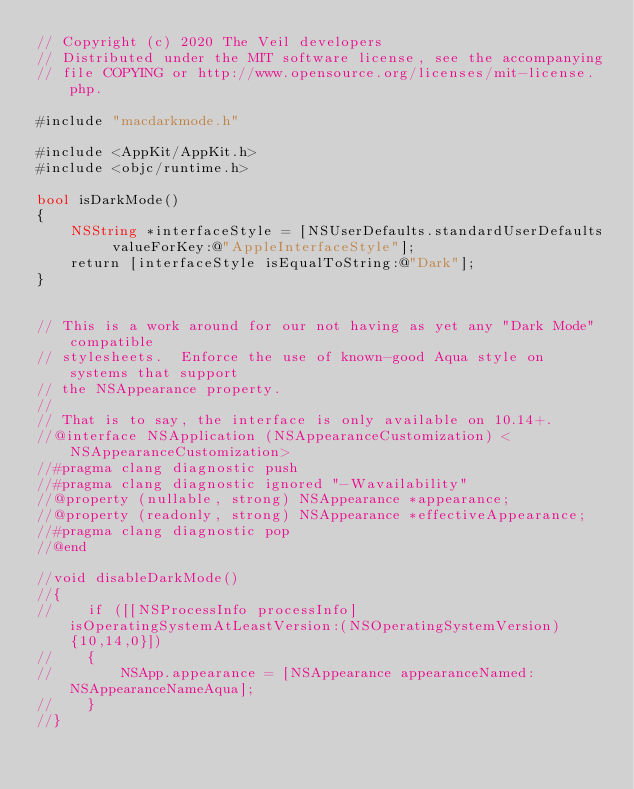Convert code to text. <code><loc_0><loc_0><loc_500><loc_500><_ObjectiveC_>// Copyright (c) 2020 The Veil developers
// Distributed under the MIT software license, see the accompanying
// file COPYING or http://www.opensource.org/licenses/mit-license.php.

#include "macdarkmode.h"

#include <AppKit/AppKit.h>
#include <objc/runtime.h>

bool isDarkMode()
{
    NSString *interfaceStyle = [NSUserDefaults.standardUserDefaults valueForKey:@"AppleInterfaceStyle"];
    return [interfaceStyle isEqualToString:@"Dark"];
}


// This is a work around for our not having as yet any "Dark Mode" compatible
// stylesheets.  Enforce the use of known-good Aqua style on systems that support
// the NSAppearance property.
//
// That is to say, the interface is only available on 10.14+.
//@interface NSApplication (NSAppearanceCustomization) <NSAppearanceCustomization>
//#pragma clang diagnostic push
//#pragma clang diagnostic ignored "-Wavailability"
//@property (nullable, strong) NSAppearance *appearance;
//@property (readonly, strong) NSAppearance *effectiveAppearance;
//#pragma clang diagnostic pop
//@end

//void disableDarkMode()
//{
//    if ([[NSProcessInfo processInfo] isOperatingSystemAtLeastVersion:(NSOperatingSystemVersion){10,14,0}])
//    {
//        NSApp.appearance = [NSAppearance appearanceNamed: NSAppearanceNameAqua];
//    }
//}

</code> 